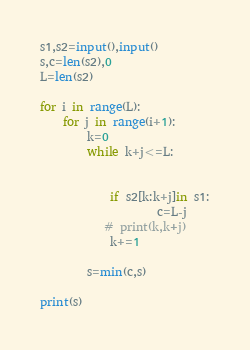<code> <loc_0><loc_0><loc_500><loc_500><_Python_>s1,s2=input(),input()
s,c=len(s2),0
L=len(s2)

for i in range(L):
    for j in range(i+1):
        k=0
        while k+j<=L:
            
            
            if s2[k:k+j]in s1:
                    c=L-j
           # print(k,k+j)
            k+=1
                
        s=min(c,s)
        
print(s)</code> 